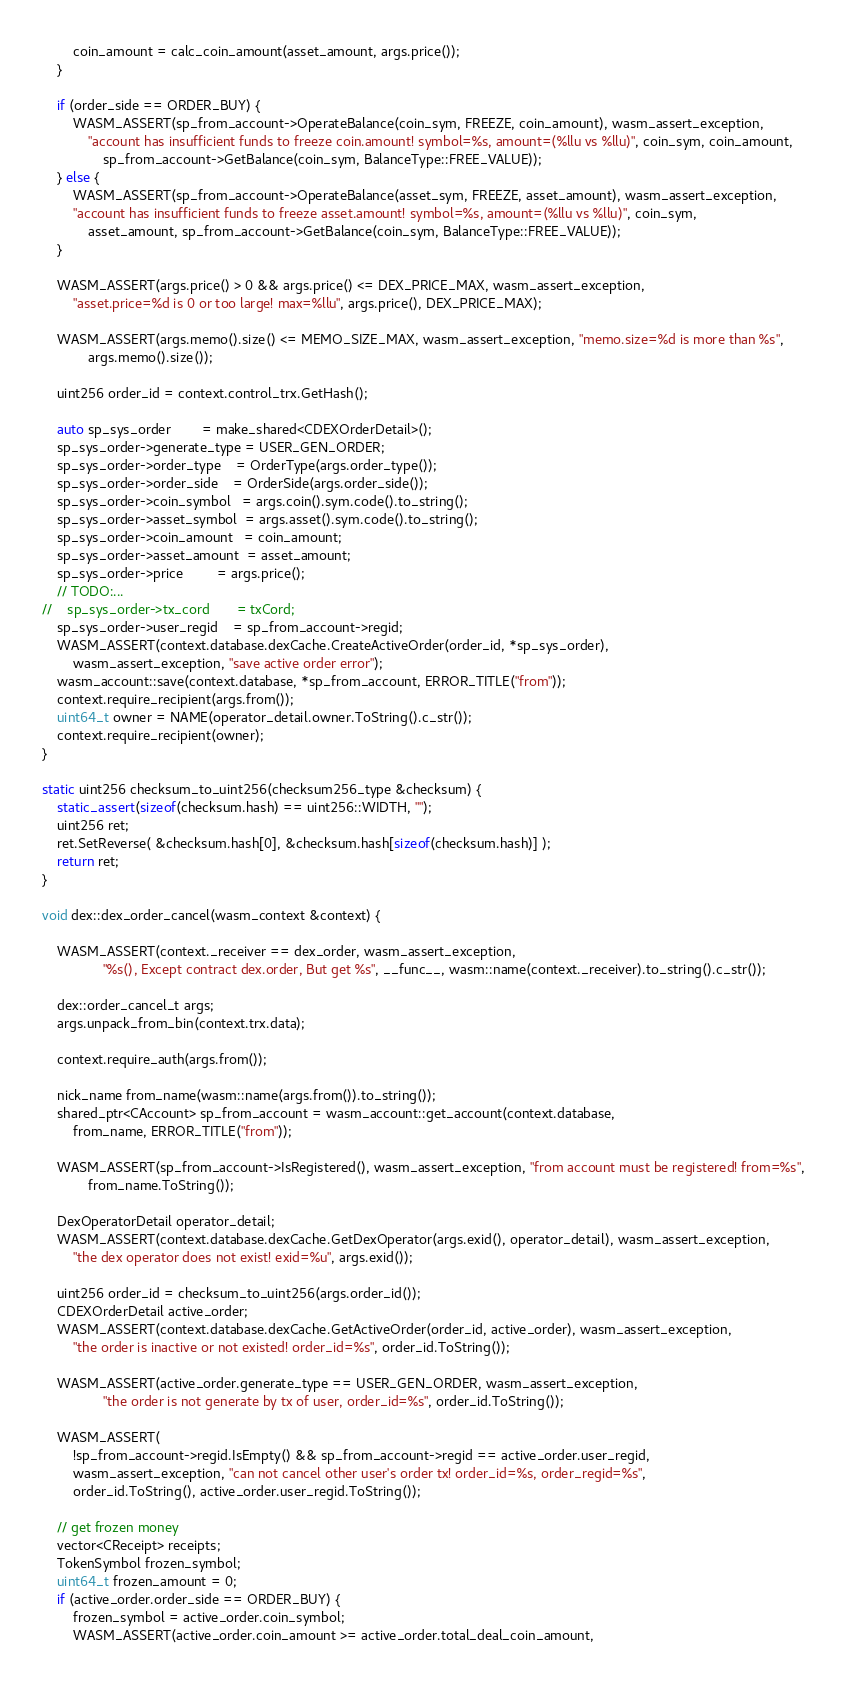<code> <loc_0><loc_0><loc_500><loc_500><_C++_>        coin_amount = calc_coin_amount(asset_amount, args.price());
    }

    if (order_side == ORDER_BUY) {
        WASM_ASSERT(sp_from_account->OperateBalance(coin_sym, FREEZE, coin_amount), wasm_assert_exception,
            "account has insufficient funds to freeze coin.amount! symbol=%s, amount=(%llu vs %llu)", coin_sym, coin_amount,
                sp_from_account->GetBalance(coin_sym, BalanceType::FREE_VALUE));
    } else {
        WASM_ASSERT(sp_from_account->OperateBalance(asset_sym, FREEZE, asset_amount), wasm_assert_exception,
        "account has insufficient funds to freeze asset.amount! symbol=%s, amount=(%llu vs %llu)", coin_sym,
            asset_amount, sp_from_account->GetBalance(coin_sym, BalanceType::FREE_VALUE));
    }

    WASM_ASSERT(args.price() > 0 && args.price() <= DEX_PRICE_MAX, wasm_assert_exception,
        "asset.price=%d is 0 or too large! max=%llu", args.price(), DEX_PRICE_MAX);

    WASM_ASSERT(args.memo().size() <= MEMO_SIZE_MAX, wasm_assert_exception, "memo.size=%d is more than %s",
            args.memo().size());

    uint256 order_id = context.control_trx.GetHash();

    auto sp_sys_order        = make_shared<CDEXOrderDetail>();
    sp_sys_order->generate_type = USER_GEN_ORDER;
    sp_sys_order->order_type    = OrderType(args.order_type());
    sp_sys_order->order_side    = OrderSide(args.order_side());
    sp_sys_order->coin_symbol   = args.coin().sym.code().to_string();
    sp_sys_order->asset_symbol  = args.asset().sym.code().to_string();
    sp_sys_order->coin_amount   = coin_amount;
    sp_sys_order->asset_amount  = asset_amount;
    sp_sys_order->price         = args.price();
    // TODO:...
//    sp_sys_order->tx_cord       = txCord;
    sp_sys_order->user_regid    = sp_from_account->regid;
    WASM_ASSERT(context.database.dexCache.CreateActiveOrder(order_id, *sp_sys_order),
        wasm_assert_exception, "save active order error");
    wasm_account::save(context.database, *sp_from_account, ERROR_TITLE("from"));
    context.require_recipient(args.from());
    uint64_t owner = NAME(operator_detail.owner.ToString().c_str());
    context.require_recipient(owner);
}

static uint256 checksum_to_uint256(checksum256_type &checksum) {
    static_assert(sizeof(checksum.hash) == uint256::WIDTH, "");
    uint256 ret;
    ret.SetReverse( &checksum.hash[0], &checksum.hash[sizeof(checksum.hash)] );
    return ret;
}

void dex::dex_order_cancel(wasm_context &context) {

    WASM_ASSERT(context._receiver == dex_order, wasm_assert_exception,
                "%s(), Except contract dex.order, But get %s", __func__, wasm::name(context._receiver).to_string().c_str());

    dex::order_cancel_t args;
    args.unpack_from_bin(context.trx.data);

    context.require_auth(args.from());

    nick_name from_name(wasm::name(args.from()).to_string());
    shared_ptr<CAccount> sp_from_account = wasm_account::get_account(context.database,
        from_name, ERROR_TITLE("from"));

    WASM_ASSERT(sp_from_account->IsRegistered(), wasm_assert_exception, "from account must be registered! from=%s",
            from_name.ToString());

    DexOperatorDetail operator_detail;
    WASM_ASSERT(context.database.dexCache.GetDexOperator(args.exid(), operator_detail), wasm_assert_exception,
        "the dex operator does not exist! exid=%u", args.exid());

    uint256 order_id = checksum_to_uint256(args.order_id());
    CDEXOrderDetail active_order;
    WASM_ASSERT(context.database.dexCache.GetActiveOrder(order_id, active_order), wasm_assert_exception,
        "the order is inactive or not existed! order_id=%s", order_id.ToString());

    WASM_ASSERT(active_order.generate_type == USER_GEN_ORDER, wasm_assert_exception,
                "the order is not generate by tx of user, order_id=%s", order_id.ToString());

    WASM_ASSERT(
        !sp_from_account->regid.IsEmpty() && sp_from_account->regid == active_order.user_regid,
        wasm_assert_exception, "can not cancel other user's order tx! order_id=%s, order_regid=%s",
        order_id.ToString(), active_order.user_regid.ToString());

    // get frozen money
    vector<CReceipt> receipts;
    TokenSymbol frozen_symbol;
    uint64_t frozen_amount = 0;
    if (active_order.order_side == ORDER_BUY) {
        frozen_symbol = active_order.coin_symbol;
        WASM_ASSERT(active_order.coin_amount >= active_order.total_deal_coin_amount,</code> 